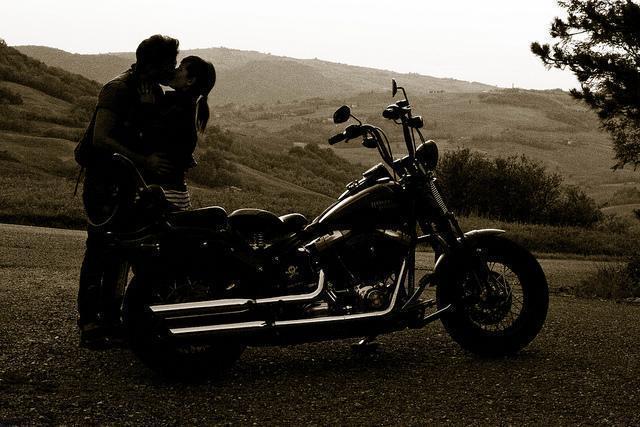What are the two feeling right now?
Pick the right solution, then justify: 'Answer: answer
Rationale: rationale.'
Options: Attraction, disgust, amusement, hate. Answer: attraction.
Rationale: The couple is kissing which presumably someone would only do with someone that they like. 